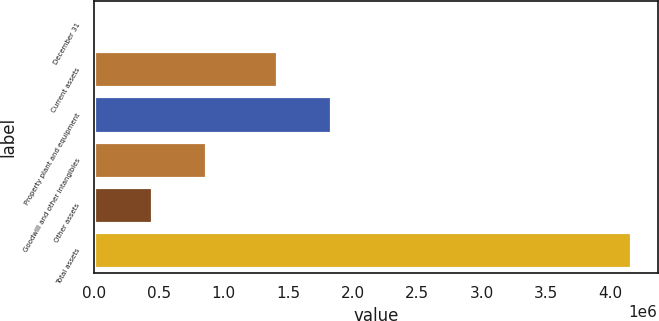Convert chart to OTSL. <chart><loc_0><loc_0><loc_500><loc_500><bar_chart><fcel>December 31<fcel>Current assets<fcel>Property plant and equipment<fcel>Goodwill and other intangibles<fcel>Other assets<fcel>Total assets<nl><fcel>2006<fcel>1.41781e+06<fcel>1.83337e+06<fcel>861740<fcel>446184<fcel>4.15756e+06<nl></chart> 